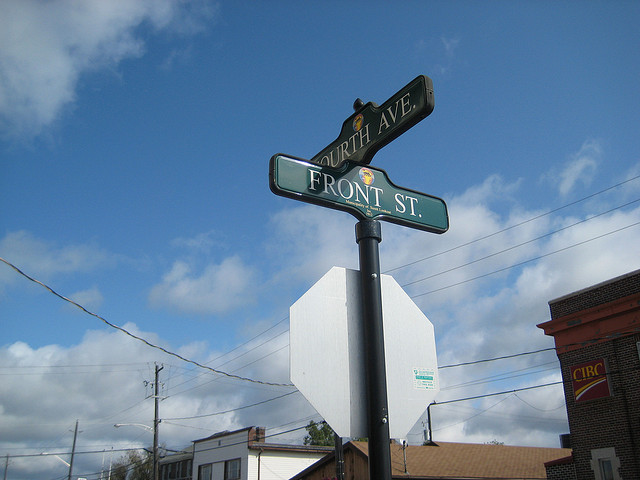Identify and read out the text in this image. FRONT ST AVE CIBC URTH 